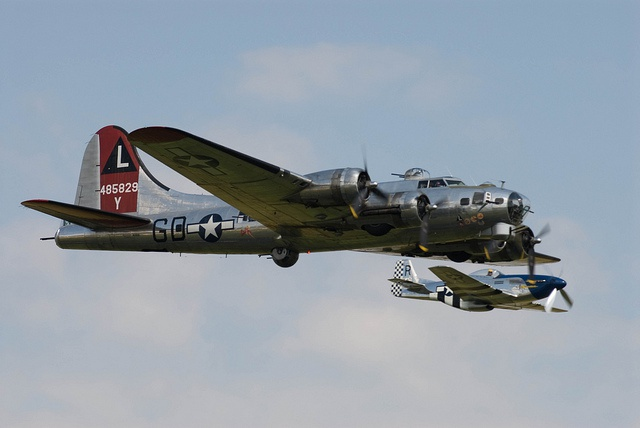Describe the objects in this image and their specific colors. I can see airplane in darkgray, black, gray, and maroon tones and airplane in darkgray, black, gray, and darkgreen tones in this image. 